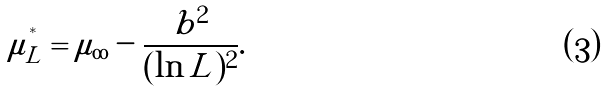<formula> <loc_0><loc_0><loc_500><loc_500>\mu _ { L } ^ { ^ { * } } = \mu _ { \infty } - \frac { b ^ { 2 } } { ( \ln L ) ^ { 2 } } .</formula> 